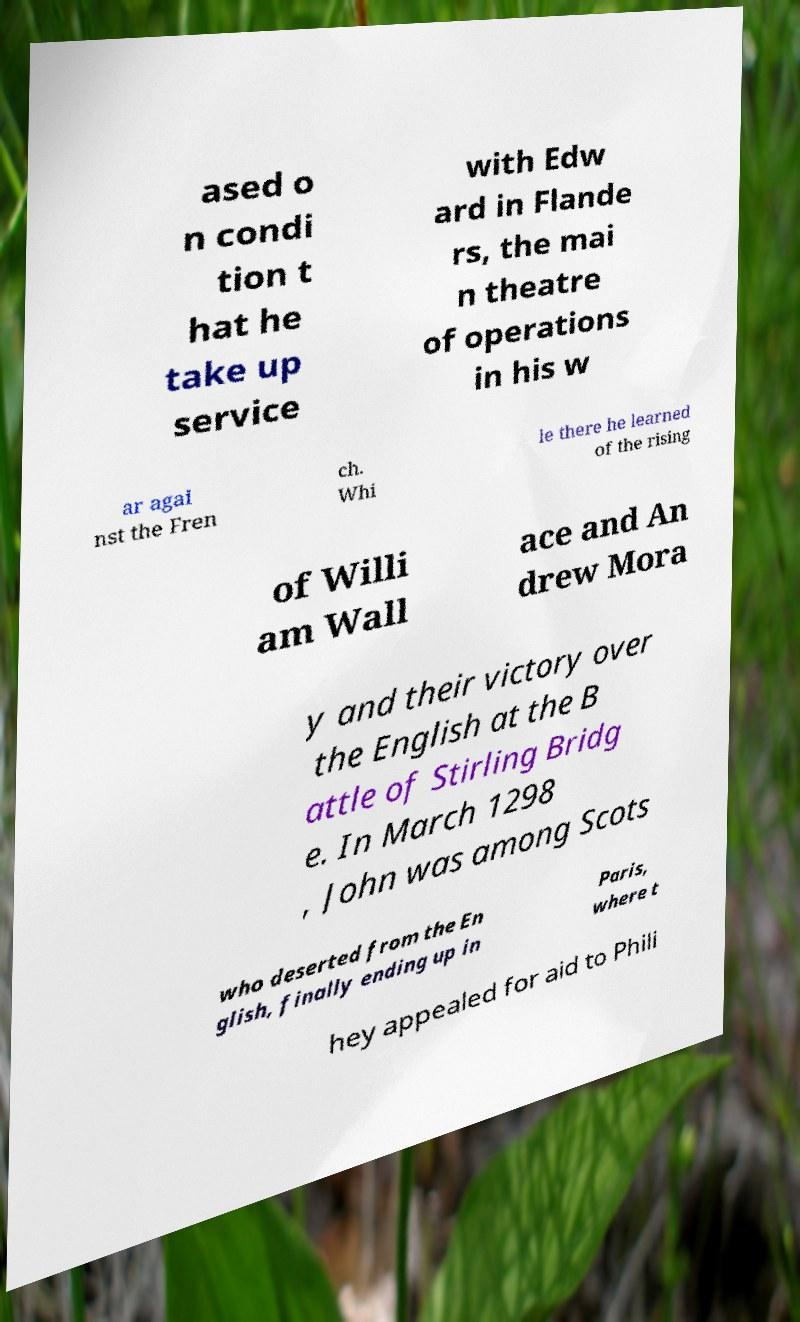Could you assist in decoding the text presented in this image and type it out clearly? ased o n condi tion t hat he take up service with Edw ard in Flande rs, the mai n theatre of operations in his w ar agai nst the Fren ch. Whi le there he learned of the rising of Willi am Wall ace and An drew Mora y and their victory over the English at the B attle of Stirling Bridg e. In March 1298 , John was among Scots who deserted from the En glish, finally ending up in Paris, where t hey appealed for aid to Phili 